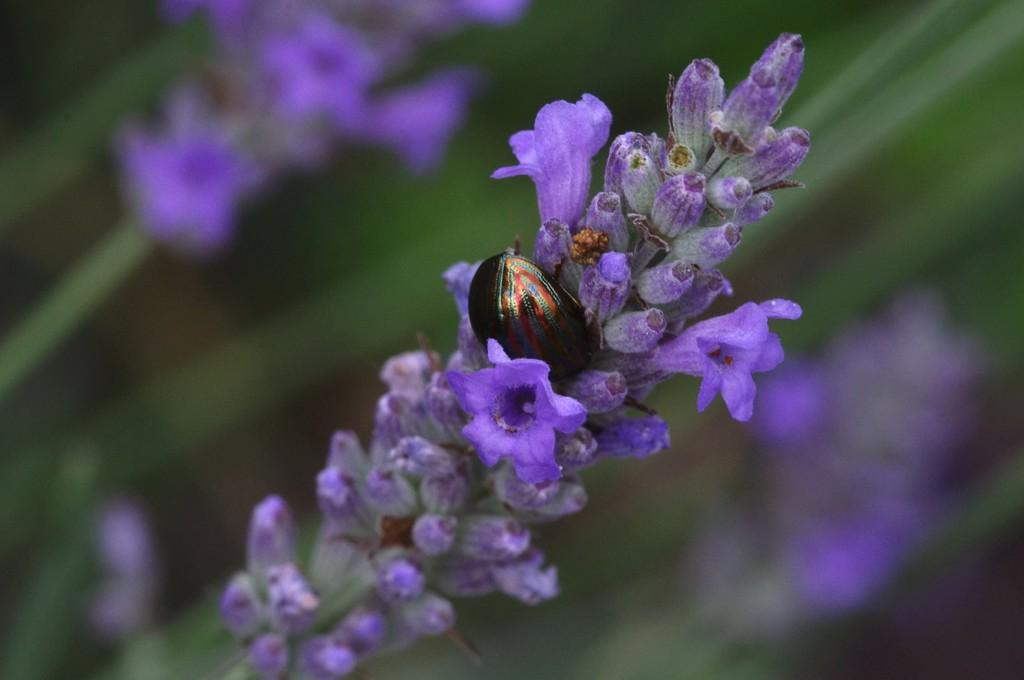What type of creature can be seen in the image? There is an insect in the image. Where is the insect located in the image? The insect is on the flowers. What is the appearance of the background in the image? The background of the image is blurred. What type of plants are visible in the image? There are flowers visible in the image. What type of pets can be seen playing with a bean in the image? There are no pets or beans present in the image; it features an insect on flowers with a blurred background. 